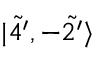<formula> <loc_0><loc_0><loc_500><loc_500>| \tilde { 4 ^ { \prime } } , - \tilde { 2 ^ { \prime } } \rangle</formula> 